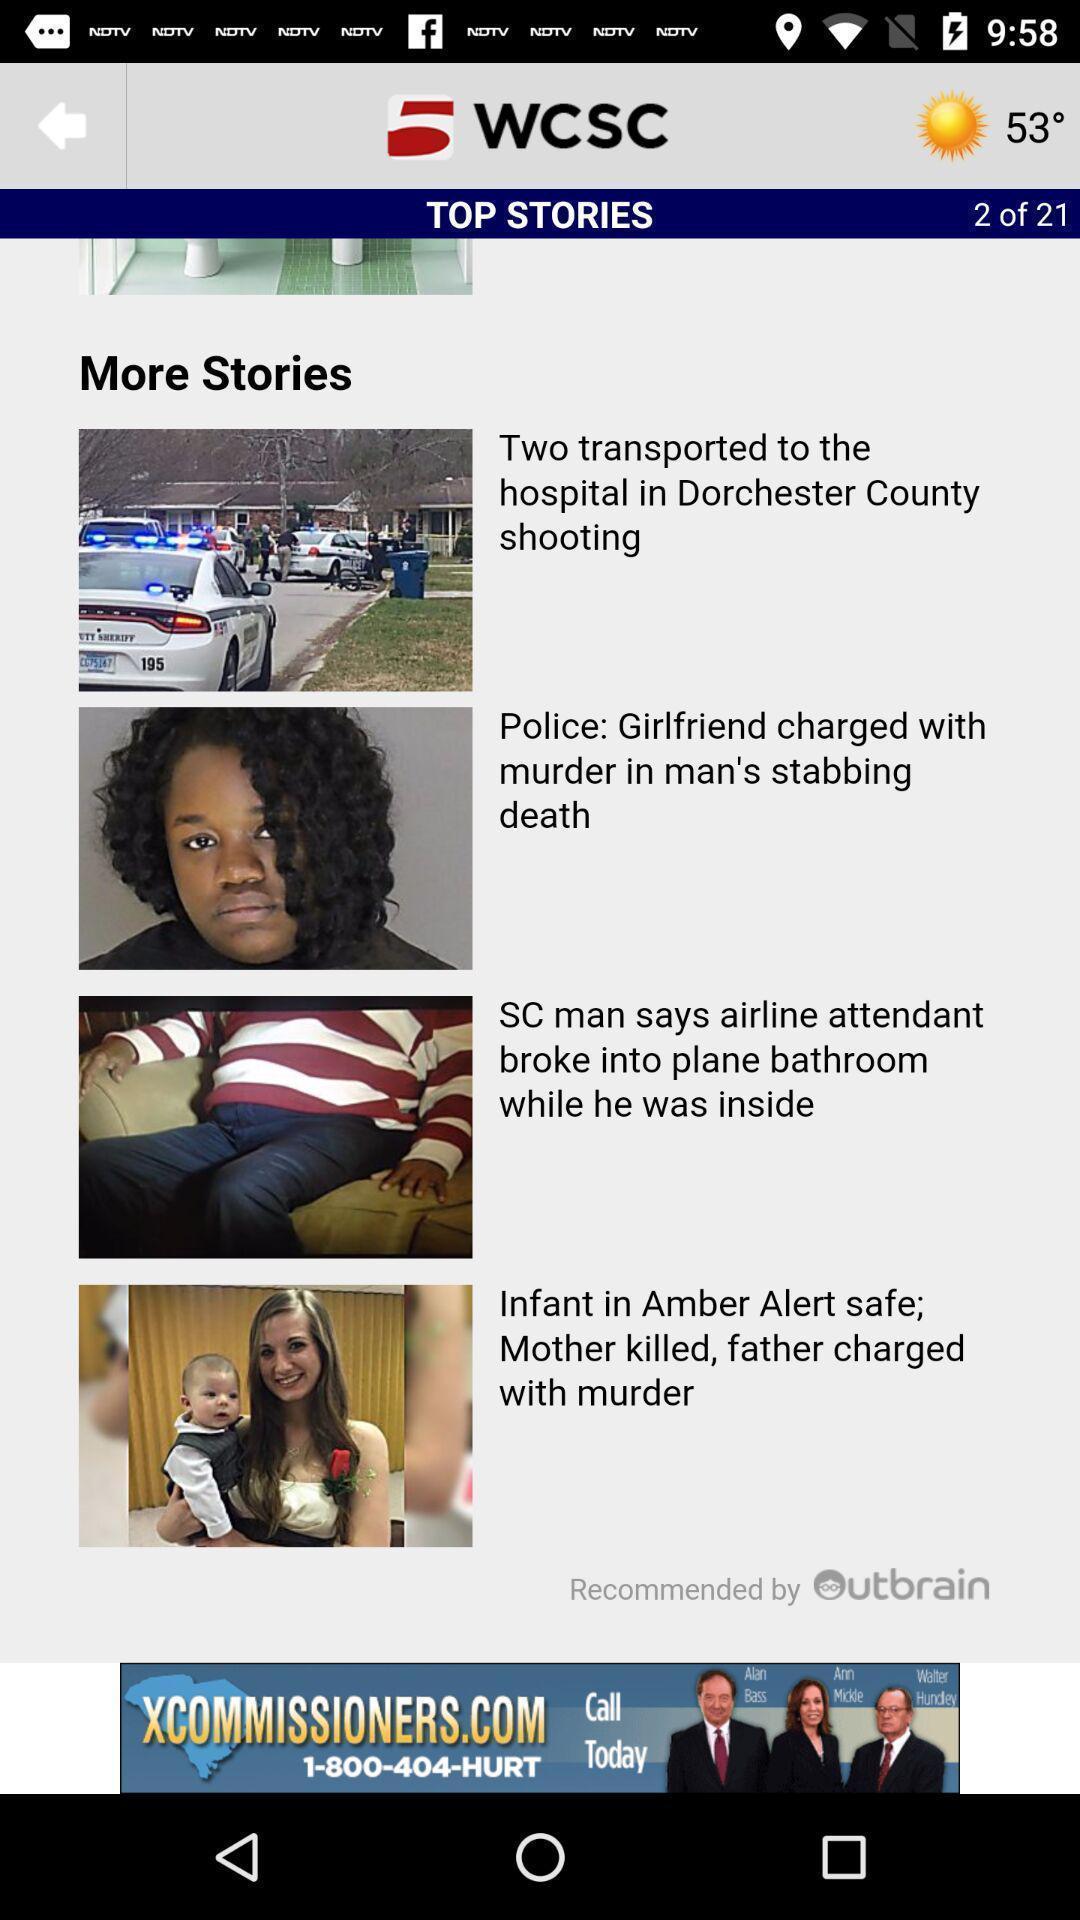Describe the visual elements of this screenshot. Screen shows top stories of a live news app. 